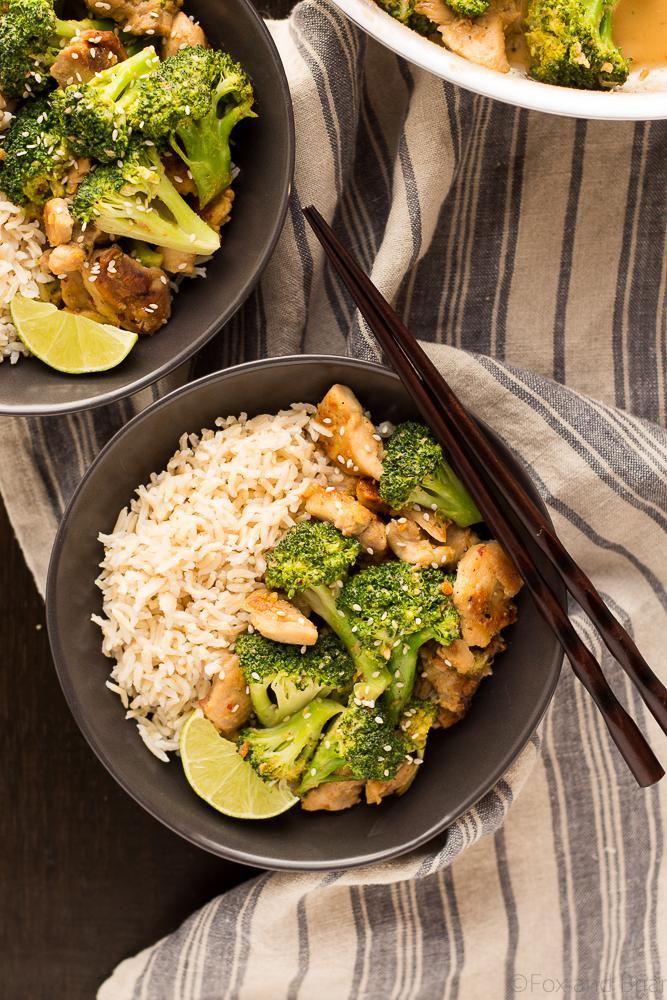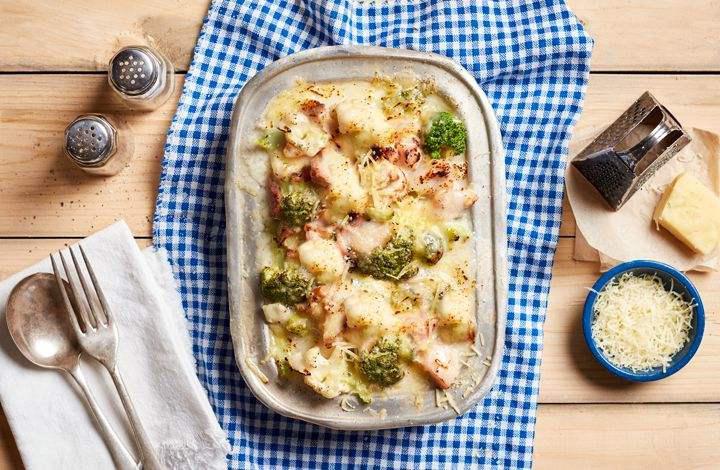The first image is the image on the left, the second image is the image on the right. Examine the images to the left and right. Is the description "One of the dishes contains broccoli and spiral pasta." accurate? Answer yes or no. No. The first image is the image on the left, the second image is the image on the right. Examine the images to the left and right. Is the description "An image shows two silverware utensils on a white napkin next to a broccoli dish." accurate? Answer yes or no. Yes. 